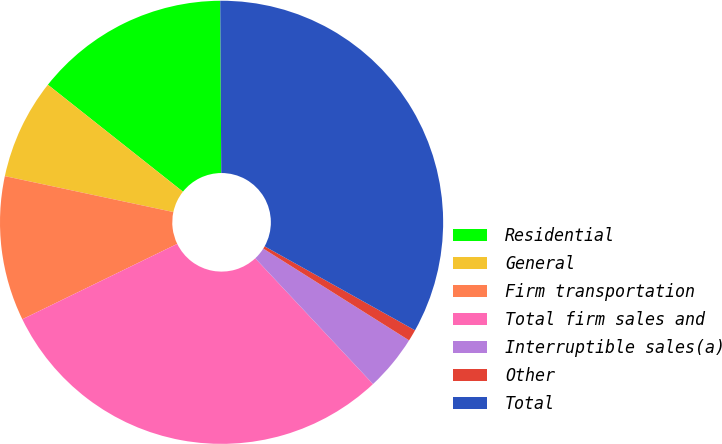Convert chart. <chart><loc_0><loc_0><loc_500><loc_500><pie_chart><fcel>Residential<fcel>General<fcel>Firm transportation<fcel>Total firm sales and<fcel>Interruptible sales(a)<fcel>Other<fcel>Total<nl><fcel>14.24%<fcel>7.32%<fcel>10.55%<fcel>29.77%<fcel>4.08%<fcel>0.84%<fcel>33.2%<nl></chart> 